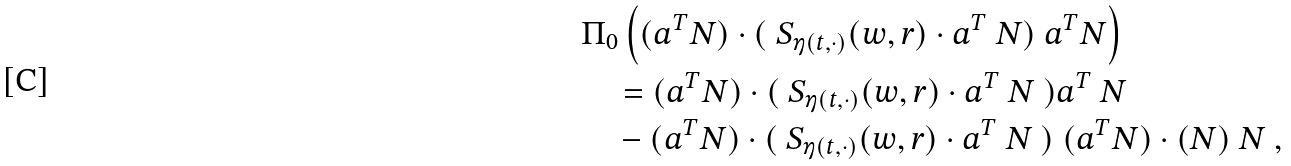Convert formula to latex. <formula><loc_0><loc_0><loc_500><loc_500>& \Pi _ { 0 } \left ( ( a ^ { T } N ) \cdot ( \ S _ { \eta ( t , \cdot ) } ( w , r ) \cdot a ^ { T } \ N ) \ a ^ { T } N \right ) \\ & \quad = ( a ^ { T } N ) \cdot ( \ S _ { \eta ( t , \cdot ) } ( w , r ) \cdot a ^ { T } \ N \ ) a ^ { T } \ N \\ & \quad - ( a ^ { T } N ) \cdot ( \ S _ { \eta ( t , \cdot ) } ( w , r ) \cdot a ^ { T } \ N \ ) \ ( a ^ { T } N ) \cdot ( N ) \ N \ ,</formula> 